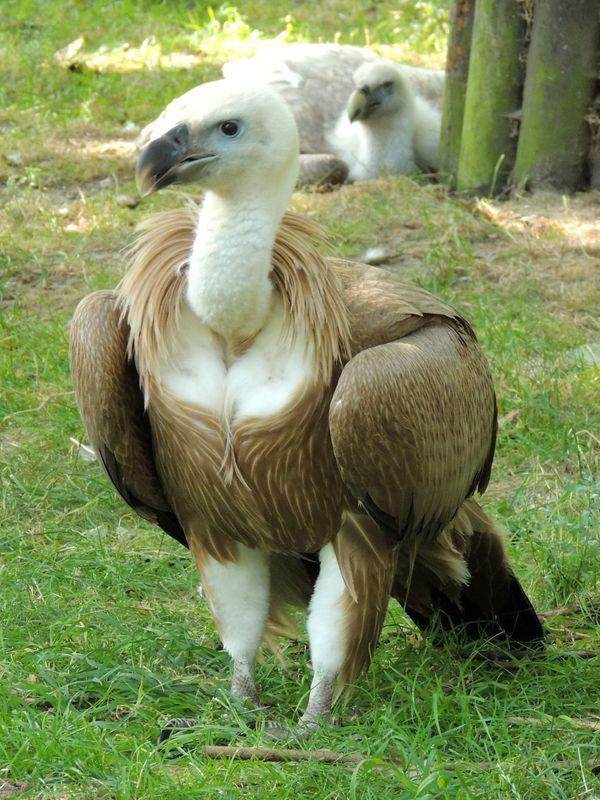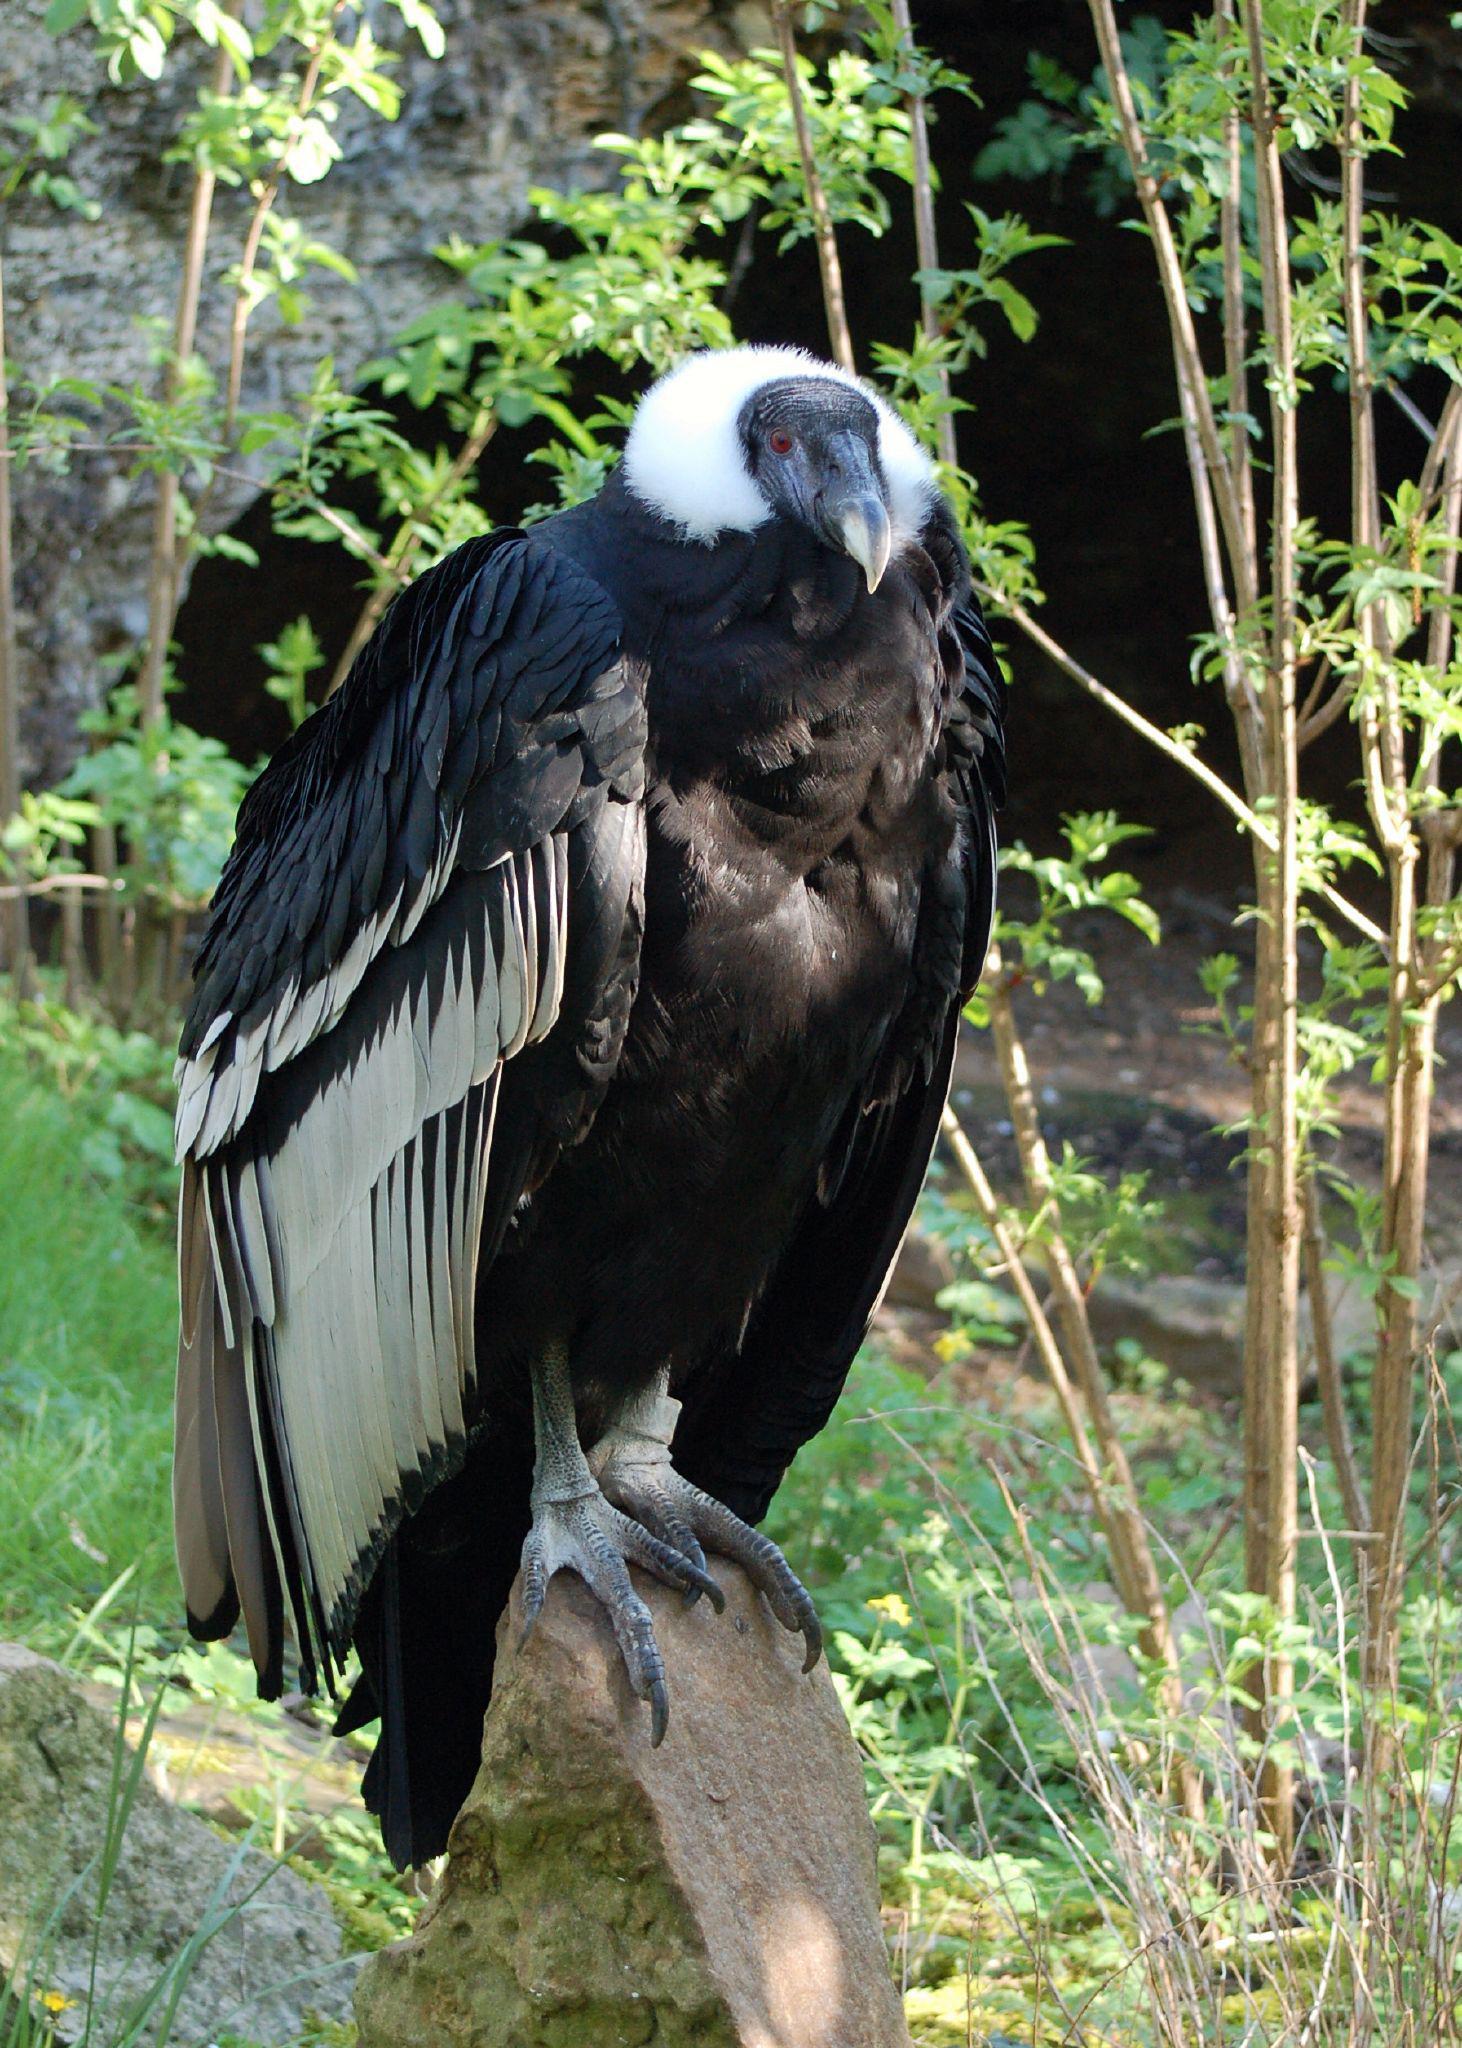The first image is the image on the left, the second image is the image on the right. Assess this claim about the two images: "The images contain baby birds". Correct or not? Answer yes or no. No. 